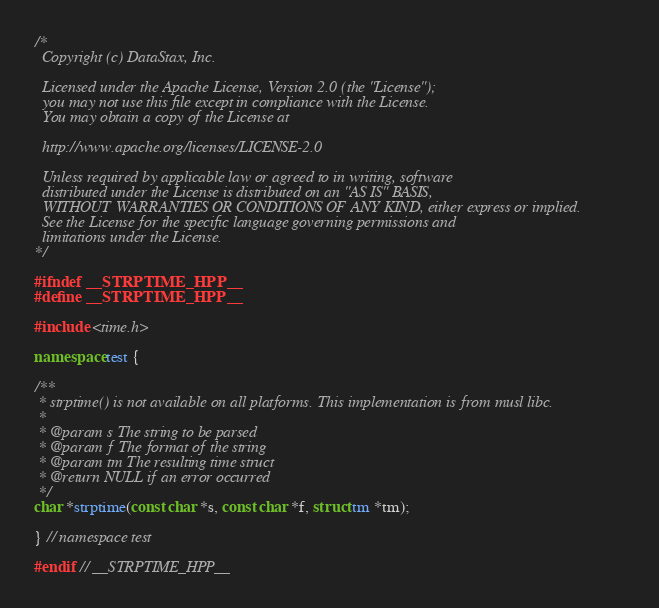Convert code to text. <code><loc_0><loc_0><loc_500><loc_500><_C++_>/*
  Copyright (c) DataStax, Inc.

  Licensed under the Apache License, Version 2.0 (the "License");
  you may not use this file except in compliance with the License.
  You may obtain a copy of the License at

  http://www.apache.org/licenses/LICENSE-2.0

  Unless required by applicable law or agreed to in writing, software
  distributed under the License is distributed on an "AS IS" BASIS,
  WITHOUT WARRANTIES OR CONDITIONS OF ANY KIND, either express or implied.
  See the License for the specific language governing permissions and
  limitations under the License.
*/

#ifndef __STRPTIME_HPP__
#define __STRPTIME_HPP__

#include <time.h>

namespace test {

/**
 * strptime() is not available on all platforms. This implementation is from musl libc.
 *
 * @param s The string to be parsed
 * @param f The format of the string
 * @param tm The resulting time struct
 * @return NULL if an error occurred
 */
char *strptime(const char *s, const char *f, struct tm *tm);

} // namespace test

#endif // __STRPTIME_HPP__
</code> 